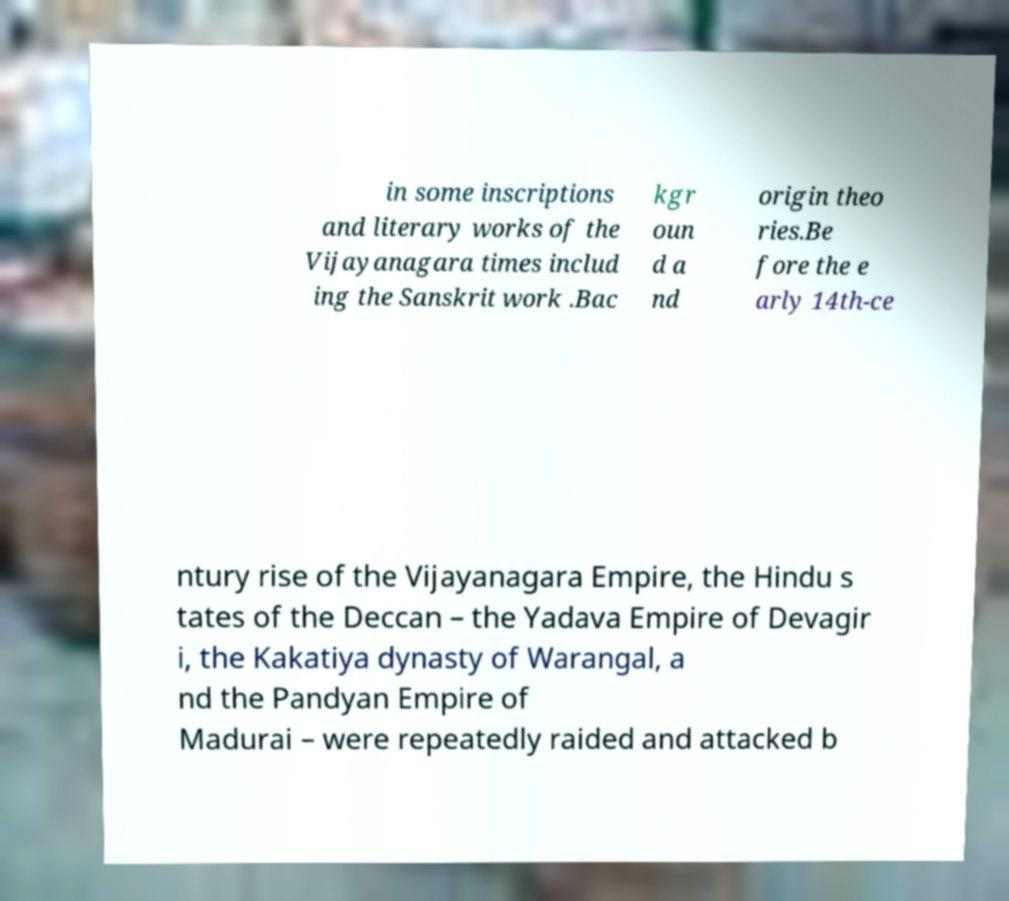What messages or text are displayed in this image? I need them in a readable, typed format. in some inscriptions and literary works of the Vijayanagara times includ ing the Sanskrit work .Bac kgr oun d a nd origin theo ries.Be fore the e arly 14th-ce ntury rise of the Vijayanagara Empire, the Hindu s tates of the Deccan – the Yadava Empire of Devagir i, the Kakatiya dynasty of Warangal, a nd the Pandyan Empire of Madurai – were repeatedly raided and attacked b 